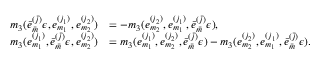Convert formula to latex. <formula><loc_0><loc_0><loc_500><loc_500>\begin{array} { r l } { m _ { 3 } ( \bar { e } _ { \bar { m } } ^ { ( \bar { j } ) } \epsilon , e _ { m _ { 1 } } ^ { ( j _ { 1 } ) } , e _ { m _ { 2 } } ^ { ( j _ { 2 } ) } ) } & { = - m _ { 3 } ( e _ { m _ { 2 } } ^ { ( j _ { 2 } ) } , e _ { m _ { 1 } } ^ { ( j _ { 1 } ) } , \bar { e } _ { \bar { m } } ^ { ( \bar { j } ) } \epsilon ) , } \\ { m _ { 3 } ( e _ { m _ { 1 } } ^ { ( j _ { 1 } ) } , \bar { e } _ { \bar { m } } ^ { ( \bar { j } ) } \epsilon , e _ { m _ { 2 } } ^ { ( j _ { 2 } ) } ) } & { = m _ { 3 } ( e _ { m _ { 1 } } ^ { ( j _ { 1 } ) } , e _ { m _ { 2 } } ^ { ( j _ { 2 } ) } , \bar { e } _ { \bar { m } } ^ { ( \bar { j } ) } \epsilon ) - m _ { 3 } ( e _ { m _ { 2 } } ^ { ( j _ { 2 } ) } , e _ { m _ { 1 } } ^ { ( j _ { 1 } ) } , \bar { e } _ { \bar { m } } ^ { ( \bar { j } ) } \epsilon ) . } \end{array}</formula> 